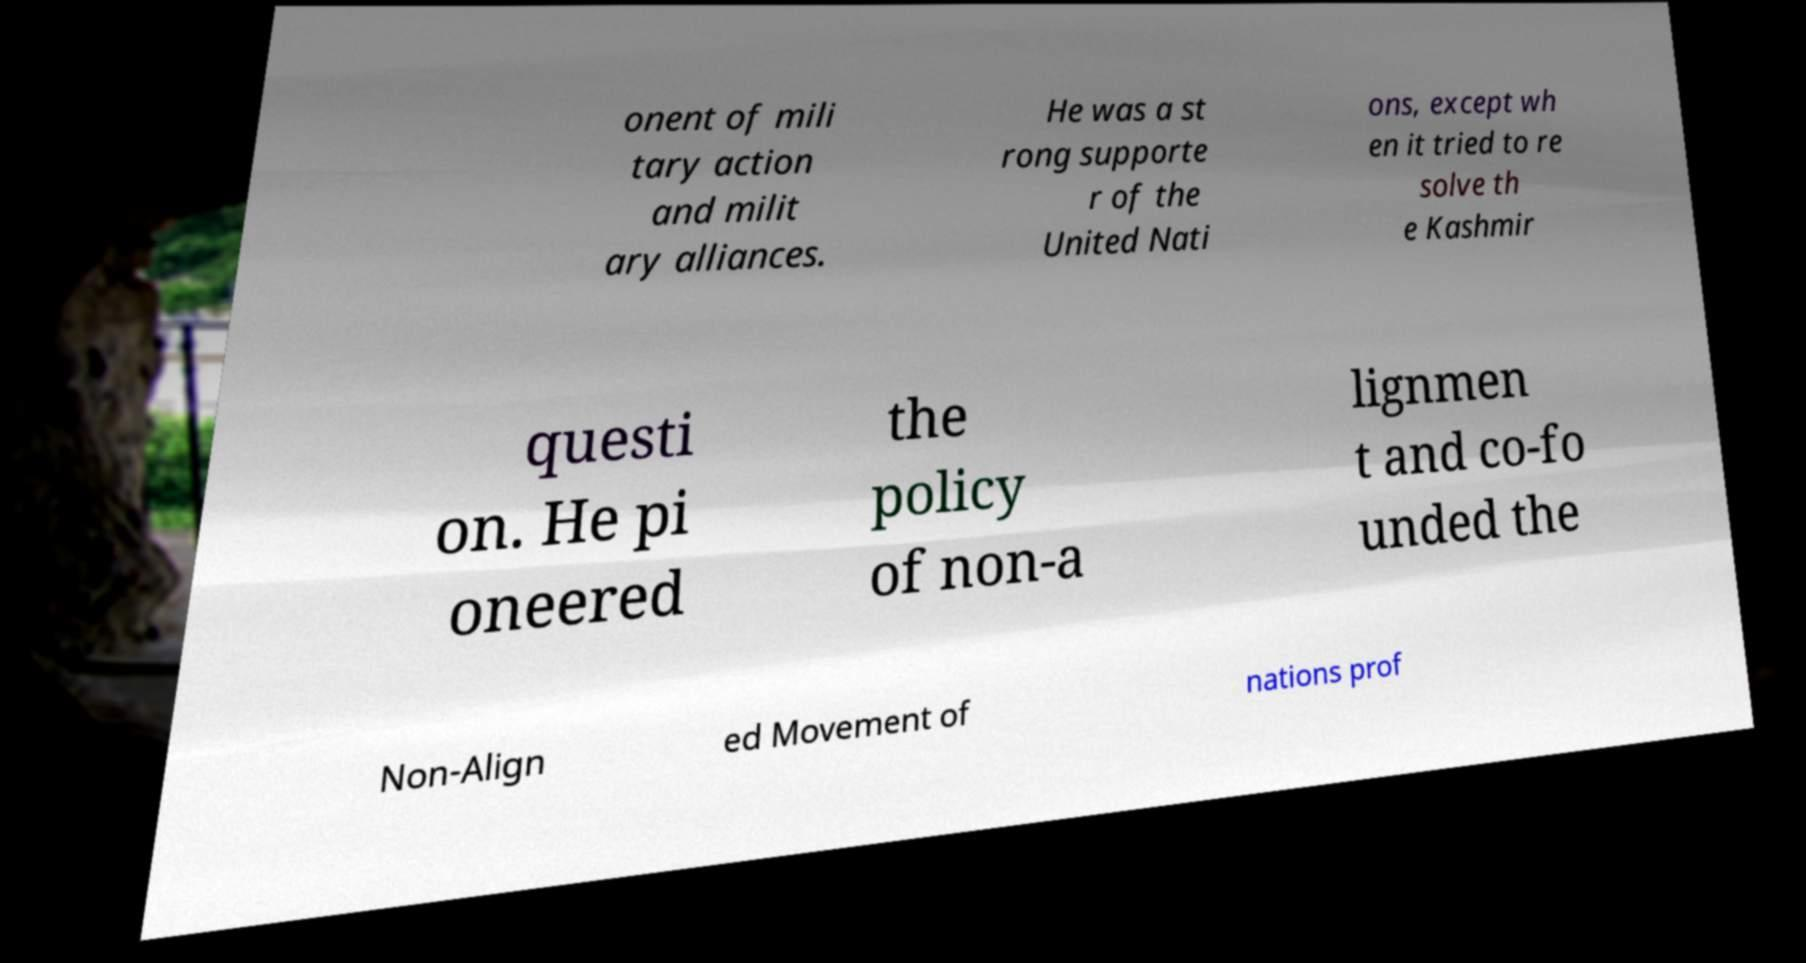What messages or text are displayed in this image? I need them in a readable, typed format. onent of mili tary action and milit ary alliances. He was a st rong supporte r of the United Nati ons, except wh en it tried to re solve th e Kashmir questi on. He pi oneered the policy of non-a lignmen t and co-fo unded the Non-Align ed Movement of nations prof 